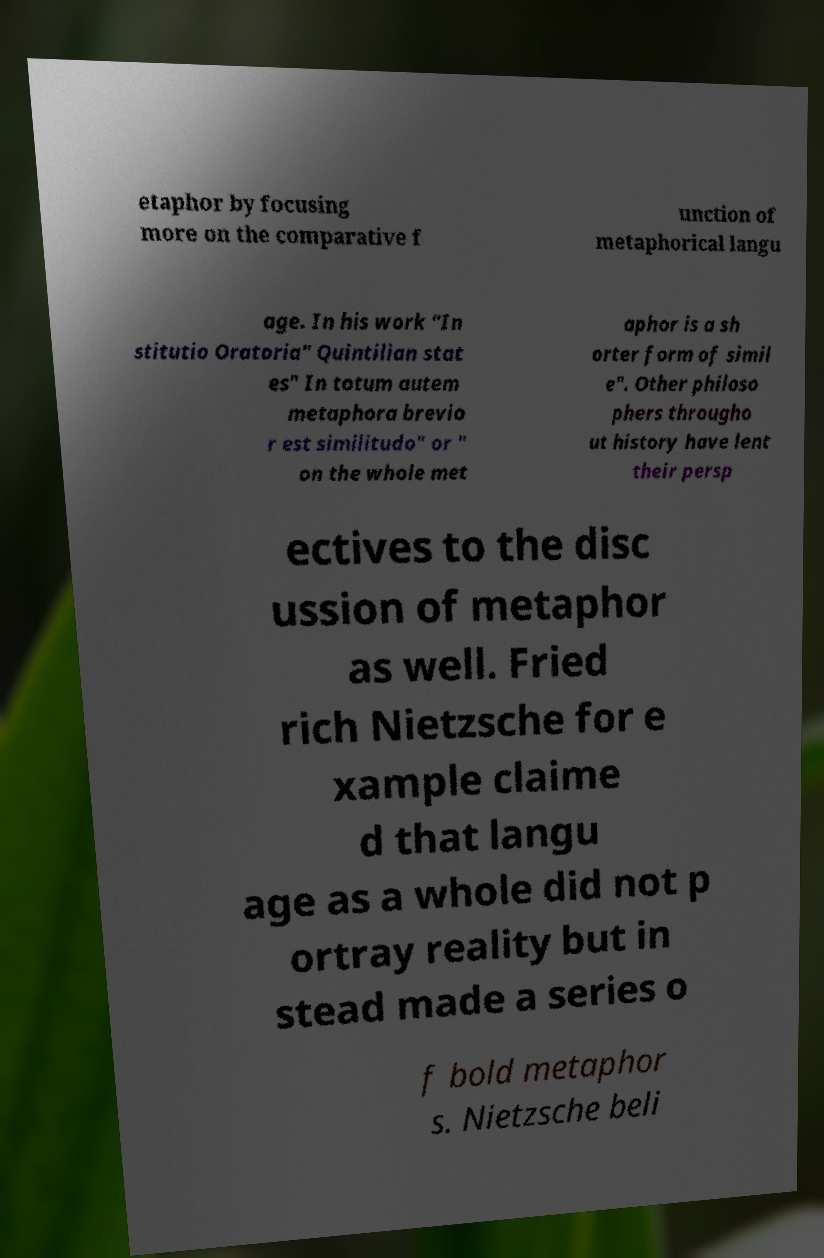Please read and relay the text visible in this image. What does it say? etaphor by focusing more on the comparative f unction of metaphorical langu age. In his work "In stitutio Oratoria" Quintilian stat es" In totum autem metaphora brevio r est similitudo" or " on the whole met aphor is a sh orter form of simil e". Other philoso phers througho ut history have lent their persp ectives to the disc ussion of metaphor as well. Fried rich Nietzsche for e xample claime d that langu age as a whole did not p ortray reality but in stead made a series o f bold metaphor s. Nietzsche beli 